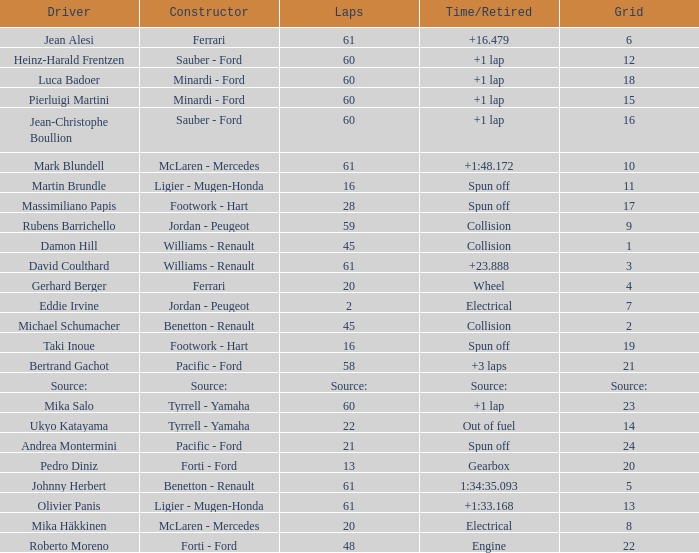What's the time/retired for a grid of 14? Out of fuel. Would you mind parsing the complete table? {'header': ['Driver', 'Constructor', 'Laps', 'Time/Retired', 'Grid'], 'rows': [['Jean Alesi', 'Ferrari', '61', '+16.479', '6'], ['Heinz-Harald Frentzen', 'Sauber - Ford', '60', '+1 lap', '12'], ['Luca Badoer', 'Minardi - Ford', '60', '+1 lap', '18'], ['Pierluigi Martini', 'Minardi - Ford', '60', '+1 lap', '15'], ['Jean-Christophe Boullion', 'Sauber - Ford', '60', '+1 lap', '16'], ['Mark Blundell', 'McLaren - Mercedes', '61', '+1:48.172', '10'], ['Martin Brundle', 'Ligier - Mugen-Honda', '16', 'Spun off', '11'], ['Massimiliano Papis', 'Footwork - Hart', '28', 'Spun off', '17'], ['Rubens Barrichello', 'Jordan - Peugeot', '59', 'Collision', '9'], ['Damon Hill', 'Williams - Renault', '45', 'Collision', '1'], ['David Coulthard', 'Williams - Renault', '61', '+23.888', '3'], ['Gerhard Berger', 'Ferrari', '20', 'Wheel', '4'], ['Eddie Irvine', 'Jordan - Peugeot', '2', 'Electrical', '7'], ['Michael Schumacher', 'Benetton - Renault', '45', 'Collision', '2'], ['Taki Inoue', 'Footwork - Hart', '16', 'Spun off', '19'], ['Bertrand Gachot', 'Pacific - Ford', '58', '+3 laps', '21'], ['Source:', 'Source:', 'Source:', 'Source:', 'Source:'], ['Mika Salo', 'Tyrrell - Yamaha', '60', '+1 lap', '23'], ['Ukyo Katayama', 'Tyrrell - Yamaha', '22', 'Out of fuel', '14'], ['Andrea Montermini', 'Pacific - Ford', '21', 'Spun off', '24'], ['Pedro Diniz', 'Forti - Ford', '13', 'Gearbox', '20'], ['Johnny Herbert', 'Benetton - Renault', '61', '1:34:35.093', '5'], ['Olivier Panis', 'Ligier - Mugen-Honda', '61', '+1:33.168', '13'], ['Mika Häkkinen', 'McLaren - Mercedes', '20', 'Electrical', '8'], ['Roberto Moreno', 'Forti - Ford', '48', 'Engine', '22']]} 